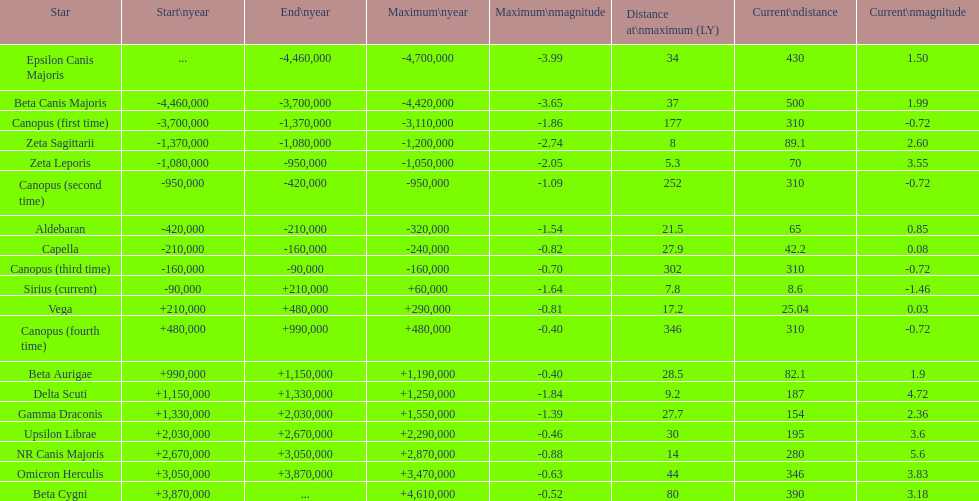Which star has the highest distance at maximum? Canopus (fourth time). 